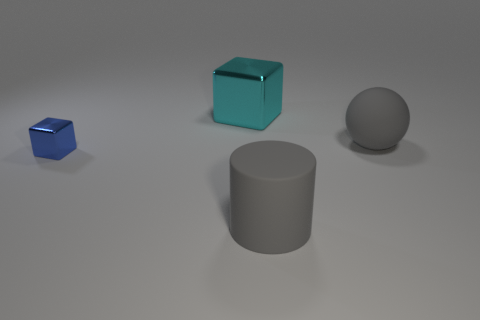Subtract all blue blocks. How many blocks are left? 1 Subtract all gray cubes. Subtract all cyan balls. How many cubes are left? 2 Subtract all yellow cylinders. How many blue cubes are left? 1 Subtract all matte spheres. Subtract all large things. How many objects are left? 0 Add 4 large gray rubber spheres. How many large gray rubber spheres are left? 5 Add 3 cyan objects. How many cyan objects exist? 4 Add 3 small objects. How many objects exist? 7 Subtract 0 green cubes. How many objects are left? 4 Subtract all cylinders. How many objects are left? 3 Subtract 1 cubes. How many cubes are left? 1 